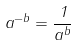Convert formula to latex. <formula><loc_0><loc_0><loc_500><loc_500>a ^ { - b } = \frac { 1 } { a ^ { b } }</formula> 